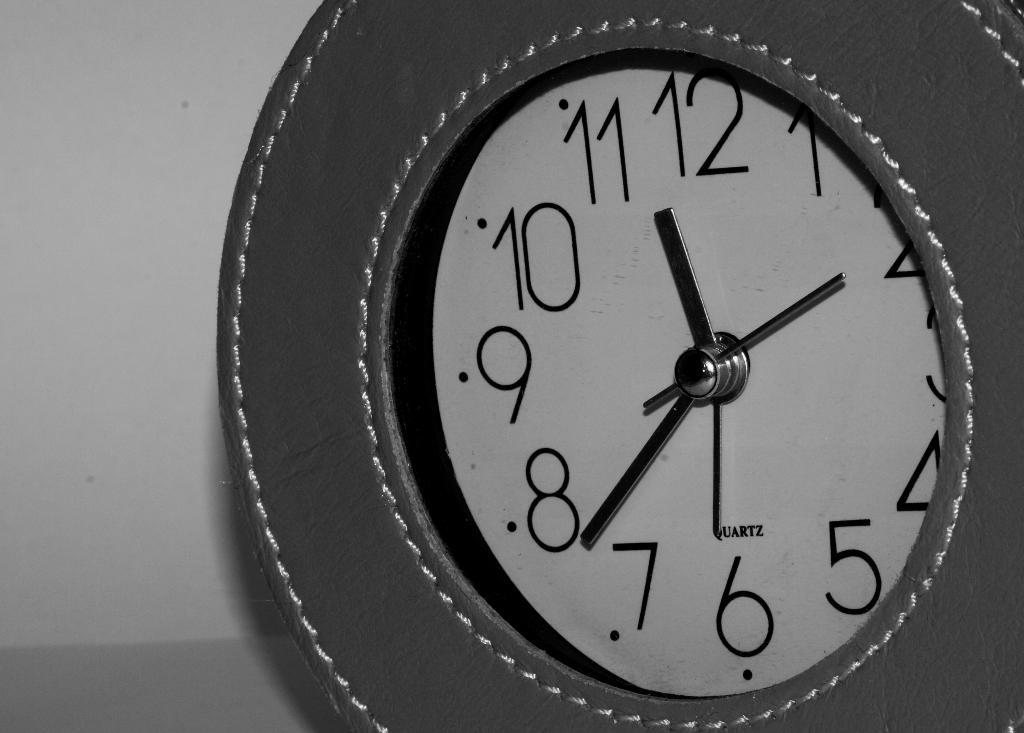<image>
Relay a brief, clear account of the picture shown. The Quartz wall clock has a nice look to it. 